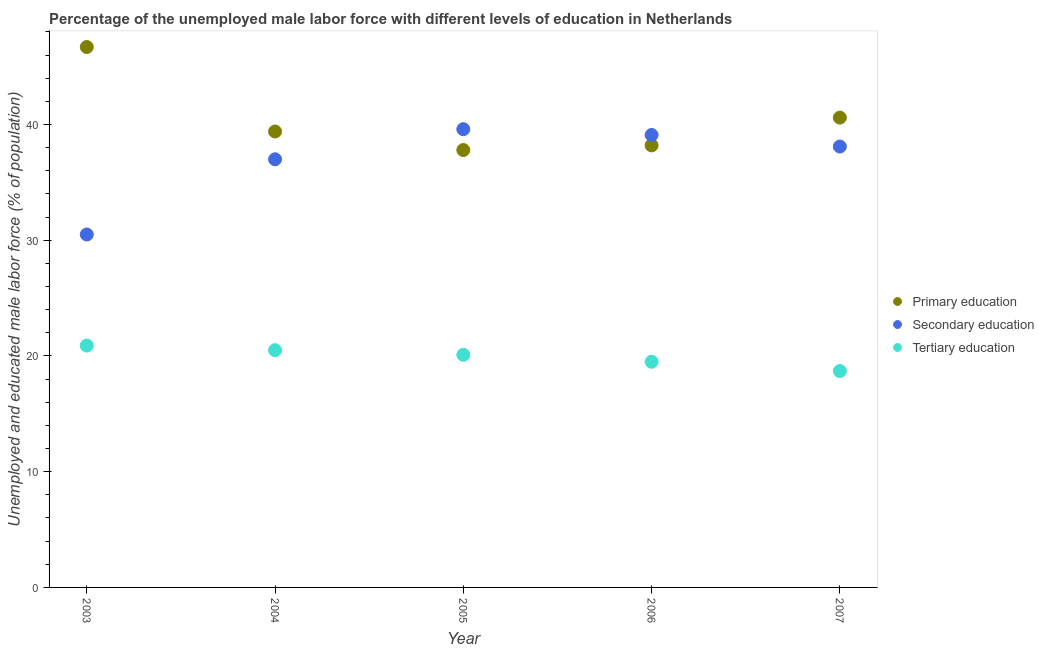How many different coloured dotlines are there?
Make the answer very short. 3. Is the number of dotlines equal to the number of legend labels?
Offer a terse response. Yes. What is the percentage of male labor force who received secondary education in 2006?
Your answer should be compact. 39.1. Across all years, what is the maximum percentage of male labor force who received tertiary education?
Make the answer very short. 20.9. Across all years, what is the minimum percentage of male labor force who received secondary education?
Offer a terse response. 30.5. In which year was the percentage of male labor force who received tertiary education maximum?
Make the answer very short. 2003. In which year was the percentage of male labor force who received tertiary education minimum?
Offer a terse response. 2007. What is the total percentage of male labor force who received primary education in the graph?
Make the answer very short. 202.7. What is the difference between the percentage of male labor force who received primary education in 2004 and that in 2007?
Provide a short and direct response. -1.2. What is the difference between the percentage of male labor force who received secondary education in 2003 and the percentage of male labor force who received primary education in 2007?
Keep it short and to the point. -10.1. What is the average percentage of male labor force who received primary education per year?
Your answer should be very brief. 40.54. In the year 2006, what is the difference between the percentage of male labor force who received secondary education and percentage of male labor force who received tertiary education?
Give a very brief answer. 19.6. In how many years, is the percentage of male labor force who received primary education greater than 36 %?
Provide a succinct answer. 5. What is the ratio of the percentage of male labor force who received secondary education in 2005 to that in 2007?
Offer a very short reply. 1.04. Is the percentage of male labor force who received tertiary education in 2004 less than that in 2005?
Offer a terse response. No. What is the difference between the highest and the second highest percentage of male labor force who received secondary education?
Your answer should be compact. 0.5. What is the difference between the highest and the lowest percentage of male labor force who received tertiary education?
Make the answer very short. 2.2. Is the sum of the percentage of male labor force who received tertiary education in 2003 and 2006 greater than the maximum percentage of male labor force who received secondary education across all years?
Offer a very short reply. Yes. Is the percentage of male labor force who received primary education strictly less than the percentage of male labor force who received secondary education over the years?
Ensure brevity in your answer.  No. How many years are there in the graph?
Ensure brevity in your answer.  5. What is the difference between two consecutive major ticks on the Y-axis?
Keep it short and to the point. 10. Does the graph contain any zero values?
Your response must be concise. No. Does the graph contain grids?
Ensure brevity in your answer.  No. Where does the legend appear in the graph?
Offer a terse response. Center right. How many legend labels are there?
Your response must be concise. 3. What is the title of the graph?
Keep it short and to the point. Percentage of the unemployed male labor force with different levels of education in Netherlands. What is the label or title of the X-axis?
Keep it short and to the point. Year. What is the label or title of the Y-axis?
Offer a terse response. Unemployed and educated male labor force (% of population). What is the Unemployed and educated male labor force (% of population) of Primary education in 2003?
Provide a short and direct response. 46.7. What is the Unemployed and educated male labor force (% of population) in Secondary education in 2003?
Provide a succinct answer. 30.5. What is the Unemployed and educated male labor force (% of population) in Tertiary education in 2003?
Offer a very short reply. 20.9. What is the Unemployed and educated male labor force (% of population) in Primary education in 2004?
Offer a terse response. 39.4. What is the Unemployed and educated male labor force (% of population) in Primary education in 2005?
Give a very brief answer. 37.8. What is the Unemployed and educated male labor force (% of population) in Secondary education in 2005?
Offer a terse response. 39.6. What is the Unemployed and educated male labor force (% of population) of Tertiary education in 2005?
Ensure brevity in your answer.  20.1. What is the Unemployed and educated male labor force (% of population) of Primary education in 2006?
Provide a short and direct response. 38.2. What is the Unemployed and educated male labor force (% of population) in Secondary education in 2006?
Ensure brevity in your answer.  39.1. What is the Unemployed and educated male labor force (% of population) in Primary education in 2007?
Give a very brief answer. 40.6. What is the Unemployed and educated male labor force (% of population) of Secondary education in 2007?
Offer a terse response. 38.1. What is the Unemployed and educated male labor force (% of population) in Tertiary education in 2007?
Provide a succinct answer. 18.7. Across all years, what is the maximum Unemployed and educated male labor force (% of population) of Primary education?
Offer a very short reply. 46.7. Across all years, what is the maximum Unemployed and educated male labor force (% of population) of Secondary education?
Your response must be concise. 39.6. Across all years, what is the maximum Unemployed and educated male labor force (% of population) of Tertiary education?
Offer a terse response. 20.9. Across all years, what is the minimum Unemployed and educated male labor force (% of population) in Primary education?
Give a very brief answer. 37.8. Across all years, what is the minimum Unemployed and educated male labor force (% of population) of Secondary education?
Make the answer very short. 30.5. Across all years, what is the minimum Unemployed and educated male labor force (% of population) of Tertiary education?
Keep it short and to the point. 18.7. What is the total Unemployed and educated male labor force (% of population) of Primary education in the graph?
Keep it short and to the point. 202.7. What is the total Unemployed and educated male labor force (% of population) of Secondary education in the graph?
Make the answer very short. 184.3. What is the total Unemployed and educated male labor force (% of population) in Tertiary education in the graph?
Make the answer very short. 99.7. What is the difference between the Unemployed and educated male labor force (% of population) in Secondary education in 2003 and that in 2004?
Keep it short and to the point. -6.5. What is the difference between the Unemployed and educated male labor force (% of population) in Primary education in 2003 and that in 2005?
Your answer should be compact. 8.9. What is the difference between the Unemployed and educated male labor force (% of population) of Tertiary education in 2003 and that in 2005?
Provide a succinct answer. 0.8. What is the difference between the Unemployed and educated male labor force (% of population) of Primary education in 2003 and that in 2006?
Give a very brief answer. 8.5. What is the difference between the Unemployed and educated male labor force (% of population) of Secondary education in 2003 and that in 2006?
Make the answer very short. -8.6. What is the difference between the Unemployed and educated male labor force (% of population) in Primary education in 2003 and that in 2007?
Offer a very short reply. 6.1. What is the difference between the Unemployed and educated male labor force (% of population) in Primary education in 2004 and that in 2006?
Offer a very short reply. 1.2. What is the difference between the Unemployed and educated male labor force (% of population) in Tertiary education in 2004 and that in 2006?
Make the answer very short. 1. What is the difference between the Unemployed and educated male labor force (% of population) of Secondary education in 2005 and that in 2006?
Your answer should be very brief. 0.5. What is the difference between the Unemployed and educated male labor force (% of population) in Primary education in 2005 and that in 2007?
Your answer should be very brief. -2.8. What is the difference between the Unemployed and educated male labor force (% of population) of Tertiary education in 2005 and that in 2007?
Your answer should be compact. 1.4. What is the difference between the Unemployed and educated male labor force (% of population) in Primary education in 2006 and that in 2007?
Offer a terse response. -2.4. What is the difference between the Unemployed and educated male labor force (% of population) in Primary education in 2003 and the Unemployed and educated male labor force (% of population) in Secondary education in 2004?
Your response must be concise. 9.7. What is the difference between the Unemployed and educated male labor force (% of population) in Primary education in 2003 and the Unemployed and educated male labor force (% of population) in Tertiary education in 2004?
Ensure brevity in your answer.  26.2. What is the difference between the Unemployed and educated male labor force (% of population) of Primary education in 2003 and the Unemployed and educated male labor force (% of population) of Tertiary education in 2005?
Offer a very short reply. 26.6. What is the difference between the Unemployed and educated male labor force (% of population) of Secondary education in 2003 and the Unemployed and educated male labor force (% of population) of Tertiary education in 2005?
Ensure brevity in your answer.  10.4. What is the difference between the Unemployed and educated male labor force (% of population) in Primary education in 2003 and the Unemployed and educated male labor force (% of population) in Secondary education in 2006?
Give a very brief answer. 7.6. What is the difference between the Unemployed and educated male labor force (% of population) in Primary education in 2003 and the Unemployed and educated male labor force (% of population) in Tertiary education in 2006?
Provide a short and direct response. 27.2. What is the difference between the Unemployed and educated male labor force (% of population) in Primary education in 2004 and the Unemployed and educated male labor force (% of population) in Secondary education in 2005?
Offer a very short reply. -0.2. What is the difference between the Unemployed and educated male labor force (% of population) of Primary education in 2004 and the Unemployed and educated male labor force (% of population) of Tertiary education in 2005?
Your answer should be very brief. 19.3. What is the difference between the Unemployed and educated male labor force (% of population) of Secondary education in 2004 and the Unemployed and educated male labor force (% of population) of Tertiary education in 2005?
Offer a very short reply. 16.9. What is the difference between the Unemployed and educated male labor force (% of population) in Primary education in 2004 and the Unemployed and educated male labor force (% of population) in Tertiary education in 2006?
Your response must be concise. 19.9. What is the difference between the Unemployed and educated male labor force (% of population) in Primary education in 2004 and the Unemployed and educated male labor force (% of population) in Tertiary education in 2007?
Your answer should be very brief. 20.7. What is the difference between the Unemployed and educated male labor force (% of population) in Primary education in 2005 and the Unemployed and educated male labor force (% of population) in Secondary education in 2006?
Provide a short and direct response. -1.3. What is the difference between the Unemployed and educated male labor force (% of population) in Secondary education in 2005 and the Unemployed and educated male labor force (% of population) in Tertiary education in 2006?
Your answer should be compact. 20.1. What is the difference between the Unemployed and educated male labor force (% of population) of Primary education in 2005 and the Unemployed and educated male labor force (% of population) of Secondary education in 2007?
Provide a short and direct response. -0.3. What is the difference between the Unemployed and educated male labor force (% of population) in Secondary education in 2005 and the Unemployed and educated male labor force (% of population) in Tertiary education in 2007?
Your response must be concise. 20.9. What is the difference between the Unemployed and educated male labor force (% of population) of Primary education in 2006 and the Unemployed and educated male labor force (% of population) of Secondary education in 2007?
Offer a terse response. 0.1. What is the difference between the Unemployed and educated male labor force (% of population) of Secondary education in 2006 and the Unemployed and educated male labor force (% of population) of Tertiary education in 2007?
Give a very brief answer. 20.4. What is the average Unemployed and educated male labor force (% of population) in Primary education per year?
Make the answer very short. 40.54. What is the average Unemployed and educated male labor force (% of population) in Secondary education per year?
Make the answer very short. 36.86. What is the average Unemployed and educated male labor force (% of population) in Tertiary education per year?
Give a very brief answer. 19.94. In the year 2003, what is the difference between the Unemployed and educated male labor force (% of population) of Primary education and Unemployed and educated male labor force (% of population) of Tertiary education?
Offer a terse response. 25.8. In the year 2004, what is the difference between the Unemployed and educated male labor force (% of population) of Primary education and Unemployed and educated male labor force (% of population) of Secondary education?
Provide a succinct answer. 2.4. In the year 2004, what is the difference between the Unemployed and educated male labor force (% of population) of Secondary education and Unemployed and educated male labor force (% of population) of Tertiary education?
Your answer should be very brief. 16.5. In the year 2005, what is the difference between the Unemployed and educated male labor force (% of population) of Primary education and Unemployed and educated male labor force (% of population) of Tertiary education?
Give a very brief answer. 17.7. In the year 2006, what is the difference between the Unemployed and educated male labor force (% of population) of Secondary education and Unemployed and educated male labor force (% of population) of Tertiary education?
Keep it short and to the point. 19.6. In the year 2007, what is the difference between the Unemployed and educated male labor force (% of population) of Primary education and Unemployed and educated male labor force (% of population) of Secondary education?
Ensure brevity in your answer.  2.5. In the year 2007, what is the difference between the Unemployed and educated male labor force (% of population) in Primary education and Unemployed and educated male labor force (% of population) in Tertiary education?
Provide a short and direct response. 21.9. What is the ratio of the Unemployed and educated male labor force (% of population) of Primary education in 2003 to that in 2004?
Provide a short and direct response. 1.19. What is the ratio of the Unemployed and educated male labor force (% of population) of Secondary education in 2003 to that in 2004?
Your answer should be very brief. 0.82. What is the ratio of the Unemployed and educated male labor force (% of population) in Tertiary education in 2003 to that in 2004?
Keep it short and to the point. 1.02. What is the ratio of the Unemployed and educated male labor force (% of population) in Primary education in 2003 to that in 2005?
Your answer should be very brief. 1.24. What is the ratio of the Unemployed and educated male labor force (% of population) of Secondary education in 2003 to that in 2005?
Provide a succinct answer. 0.77. What is the ratio of the Unemployed and educated male labor force (% of population) of Tertiary education in 2003 to that in 2005?
Give a very brief answer. 1.04. What is the ratio of the Unemployed and educated male labor force (% of population) in Primary education in 2003 to that in 2006?
Keep it short and to the point. 1.22. What is the ratio of the Unemployed and educated male labor force (% of population) in Secondary education in 2003 to that in 2006?
Give a very brief answer. 0.78. What is the ratio of the Unemployed and educated male labor force (% of population) in Tertiary education in 2003 to that in 2006?
Your response must be concise. 1.07. What is the ratio of the Unemployed and educated male labor force (% of population) in Primary education in 2003 to that in 2007?
Your answer should be very brief. 1.15. What is the ratio of the Unemployed and educated male labor force (% of population) in Secondary education in 2003 to that in 2007?
Your answer should be very brief. 0.8. What is the ratio of the Unemployed and educated male labor force (% of population) of Tertiary education in 2003 to that in 2007?
Your response must be concise. 1.12. What is the ratio of the Unemployed and educated male labor force (% of population) in Primary education in 2004 to that in 2005?
Offer a terse response. 1.04. What is the ratio of the Unemployed and educated male labor force (% of population) in Secondary education in 2004 to that in 2005?
Offer a very short reply. 0.93. What is the ratio of the Unemployed and educated male labor force (% of population) of Tertiary education in 2004 to that in 2005?
Give a very brief answer. 1.02. What is the ratio of the Unemployed and educated male labor force (% of population) in Primary education in 2004 to that in 2006?
Make the answer very short. 1.03. What is the ratio of the Unemployed and educated male labor force (% of population) of Secondary education in 2004 to that in 2006?
Your answer should be very brief. 0.95. What is the ratio of the Unemployed and educated male labor force (% of population) of Tertiary education in 2004 to that in 2006?
Provide a short and direct response. 1.05. What is the ratio of the Unemployed and educated male labor force (% of population) of Primary education in 2004 to that in 2007?
Offer a terse response. 0.97. What is the ratio of the Unemployed and educated male labor force (% of population) in Secondary education in 2004 to that in 2007?
Offer a very short reply. 0.97. What is the ratio of the Unemployed and educated male labor force (% of population) in Tertiary education in 2004 to that in 2007?
Your answer should be very brief. 1.1. What is the ratio of the Unemployed and educated male labor force (% of population) in Primary education in 2005 to that in 2006?
Make the answer very short. 0.99. What is the ratio of the Unemployed and educated male labor force (% of population) of Secondary education in 2005 to that in 2006?
Provide a succinct answer. 1.01. What is the ratio of the Unemployed and educated male labor force (% of population) of Tertiary education in 2005 to that in 2006?
Offer a very short reply. 1.03. What is the ratio of the Unemployed and educated male labor force (% of population) in Primary education in 2005 to that in 2007?
Your answer should be very brief. 0.93. What is the ratio of the Unemployed and educated male labor force (% of population) in Secondary education in 2005 to that in 2007?
Make the answer very short. 1.04. What is the ratio of the Unemployed and educated male labor force (% of population) of Tertiary education in 2005 to that in 2007?
Provide a short and direct response. 1.07. What is the ratio of the Unemployed and educated male labor force (% of population) of Primary education in 2006 to that in 2007?
Your answer should be compact. 0.94. What is the ratio of the Unemployed and educated male labor force (% of population) of Secondary education in 2006 to that in 2007?
Offer a terse response. 1.03. What is the ratio of the Unemployed and educated male labor force (% of population) of Tertiary education in 2006 to that in 2007?
Make the answer very short. 1.04. What is the difference between the highest and the lowest Unemployed and educated male labor force (% of population) in Secondary education?
Ensure brevity in your answer.  9.1. 